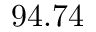Convert formula to latex. <formula><loc_0><loc_0><loc_500><loc_500>9 4 . 7 4 \</formula> 